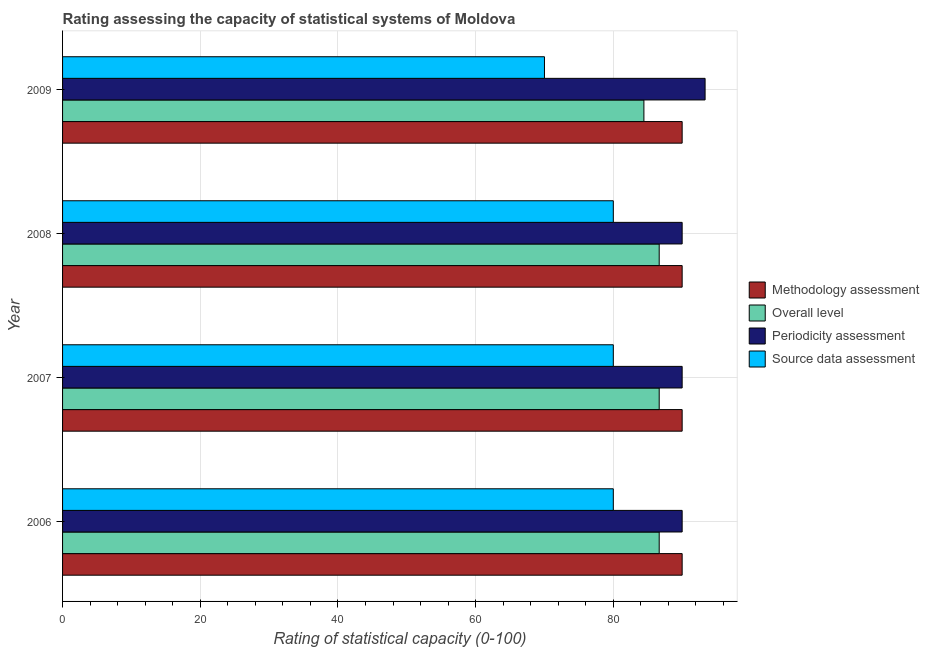How many different coloured bars are there?
Keep it short and to the point. 4. Are the number of bars per tick equal to the number of legend labels?
Your response must be concise. Yes. Are the number of bars on each tick of the Y-axis equal?
Provide a succinct answer. Yes. How many bars are there on the 1st tick from the top?
Your answer should be compact. 4. What is the periodicity assessment rating in 2009?
Keep it short and to the point. 93.33. Across all years, what is the maximum source data assessment rating?
Offer a terse response. 80. Across all years, what is the minimum overall level rating?
Your answer should be very brief. 84.44. In which year was the source data assessment rating minimum?
Provide a short and direct response. 2009. What is the total source data assessment rating in the graph?
Your response must be concise. 310. What is the difference between the overall level rating in 2006 and that in 2009?
Your response must be concise. 2.22. What is the difference between the source data assessment rating in 2008 and the methodology assessment rating in 2009?
Ensure brevity in your answer.  -10. In the year 2009, what is the difference between the periodicity assessment rating and source data assessment rating?
Keep it short and to the point. 23.33. What is the ratio of the source data assessment rating in 2007 to that in 2008?
Keep it short and to the point. 1. What is the difference between the highest and the second highest overall level rating?
Your answer should be very brief. 0. What is the difference between the highest and the lowest periodicity assessment rating?
Provide a succinct answer. 3.33. In how many years, is the source data assessment rating greater than the average source data assessment rating taken over all years?
Provide a succinct answer. 3. Is the sum of the methodology assessment rating in 2006 and 2007 greater than the maximum source data assessment rating across all years?
Offer a terse response. Yes. Is it the case that in every year, the sum of the methodology assessment rating and periodicity assessment rating is greater than the sum of source data assessment rating and overall level rating?
Your answer should be very brief. No. What does the 3rd bar from the top in 2006 represents?
Offer a terse response. Overall level. What does the 4th bar from the bottom in 2006 represents?
Ensure brevity in your answer.  Source data assessment. Is it the case that in every year, the sum of the methodology assessment rating and overall level rating is greater than the periodicity assessment rating?
Keep it short and to the point. Yes. How many legend labels are there?
Keep it short and to the point. 4. What is the title of the graph?
Provide a short and direct response. Rating assessing the capacity of statistical systems of Moldova. Does "Second 20% of population" appear as one of the legend labels in the graph?
Offer a very short reply. No. What is the label or title of the X-axis?
Keep it short and to the point. Rating of statistical capacity (0-100). What is the Rating of statistical capacity (0-100) of Overall level in 2006?
Your answer should be compact. 86.67. What is the Rating of statistical capacity (0-100) in Methodology assessment in 2007?
Offer a very short reply. 90. What is the Rating of statistical capacity (0-100) of Overall level in 2007?
Provide a succinct answer. 86.67. What is the Rating of statistical capacity (0-100) of Periodicity assessment in 2007?
Your answer should be compact. 90. What is the Rating of statistical capacity (0-100) of Source data assessment in 2007?
Offer a very short reply. 80. What is the Rating of statistical capacity (0-100) of Methodology assessment in 2008?
Provide a succinct answer. 90. What is the Rating of statistical capacity (0-100) of Overall level in 2008?
Your response must be concise. 86.67. What is the Rating of statistical capacity (0-100) of Periodicity assessment in 2008?
Ensure brevity in your answer.  90. What is the Rating of statistical capacity (0-100) in Source data assessment in 2008?
Keep it short and to the point. 80. What is the Rating of statistical capacity (0-100) in Methodology assessment in 2009?
Ensure brevity in your answer.  90. What is the Rating of statistical capacity (0-100) of Overall level in 2009?
Make the answer very short. 84.44. What is the Rating of statistical capacity (0-100) of Periodicity assessment in 2009?
Offer a terse response. 93.33. What is the Rating of statistical capacity (0-100) of Source data assessment in 2009?
Keep it short and to the point. 70. Across all years, what is the maximum Rating of statistical capacity (0-100) in Methodology assessment?
Your answer should be compact. 90. Across all years, what is the maximum Rating of statistical capacity (0-100) of Overall level?
Ensure brevity in your answer.  86.67. Across all years, what is the maximum Rating of statistical capacity (0-100) in Periodicity assessment?
Your response must be concise. 93.33. Across all years, what is the maximum Rating of statistical capacity (0-100) of Source data assessment?
Make the answer very short. 80. Across all years, what is the minimum Rating of statistical capacity (0-100) in Methodology assessment?
Your response must be concise. 90. Across all years, what is the minimum Rating of statistical capacity (0-100) of Overall level?
Provide a succinct answer. 84.44. What is the total Rating of statistical capacity (0-100) of Methodology assessment in the graph?
Provide a succinct answer. 360. What is the total Rating of statistical capacity (0-100) of Overall level in the graph?
Offer a terse response. 344.44. What is the total Rating of statistical capacity (0-100) of Periodicity assessment in the graph?
Provide a succinct answer. 363.33. What is the total Rating of statistical capacity (0-100) of Source data assessment in the graph?
Keep it short and to the point. 310. What is the difference between the Rating of statistical capacity (0-100) of Overall level in 2006 and that in 2007?
Provide a succinct answer. 0. What is the difference between the Rating of statistical capacity (0-100) of Periodicity assessment in 2006 and that in 2007?
Offer a very short reply. 0. What is the difference between the Rating of statistical capacity (0-100) of Source data assessment in 2006 and that in 2007?
Ensure brevity in your answer.  0. What is the difference between the Rating of statistical capacity (0-100) in Methodology assessment in 2006 and that in 2008?
Offer a very short reply. 0. What is the difference between the Rating of statistical capacity (0-100) of Methodology assessment in 2006 and that in 2009?
Provide a succinct answer. 0. What is the difference between the Rating of statistical capacity (0-100) of Overall level in 2006 and that in 2009?
Your answer should be very brief. 2.22. What is the difference between the Rating of statistical capacity (0-100) of Periodicity assessment in 2006 and that in 2009?
Offer a very short reply. -3.33. What is the difference between the Rating of statistical capacity (0-100) in Source data assessment in 2006 and that in 2009?
Make the answer very short. 10. What is the difference between the Rating of statistical capacity (0-100) of Overall level in 2007 and that in 2008?
Your response must be concise. 0. What is the difference between the Rating of statistical capacity (0-100) in Periodicity assessment in 2007 and that in 2008?
Offer a very short reply. 0. What is the difference between the Rating of statistical capacity (0-100) of Source data assessment in 2007 and that in 2008?
Your answer should be very brief. 0. What is the difference between the Rating of statistical capacity (0-100) in Overall level in 2007 and that in 2009?
Your answer should be compact. 2.22. What is the difference between the Rating of statistical capacity (0-100) in Source data assessment in 2007 and that in 2009?
Offer a very short reply. 10. What is the difference between the Rating of statistical capacity (0-100) in Overall level in 2008 and that in 2009?
Your answer should be very brief. 2.22. What is the difference between the Rating of statistical capacity (0-100) in Periodicity assessment in 2008 and that in 2009?
Give a very brief answer. -3.33. What is the difference between the Rating of statistical capacity (0-100) in Source data assessment in 2008 and that in 2009?
Provide a succinct answer. 10. What is the difference between the Rating of statistical capacity (0-100) in Methodology assessment in 2006 and the Rating of statistical capacity (0-100) in Overall level in 2007?
Provide a succinct answer. 3.33. What is the difference between the Rating of statistical capacity (0-100) in Periodicity assessment in 2006 and the Rating of statistical capacity (0-100) in Source data assessment in 2007?
Offer a very short reply. 10. What is the difference between the Rating of statistical capacity (0-100) in Methodology assessment in 2006 and the Rating of statistical capacity (0-100) in Overall level in 2008?
Provide a short and direct response. 3.33. What is the difference between the Rating of statistical capacity (0-100) of Methodology assessment in 2006 and the Rating of statistical capacity (0-100) of Periodicity assessment in 2008?
Your answer should be very brief. 0. What is the difference between the Rating of statistical capacity (0-100) in Overall level in 2006 and the Rating of statistical capacity (0-100) in Source data assessment in 2008?
Make the answer very short. 6.67. What is the difference between the Rating of statistical capacity (0-100) of Methodology assessment in 2006 and the Rating of statistical capacity (0-100) of Overall level in 2009?
Provide a short and direct response. 5.56. What is the difference between the Rating of statistical capacity (0-100) in Methodology assessment in 2006 and the Rating of statistical capacity (0-100) in Periodicity assessment in 2009?
Offer a terse response. -3.33. What is the difference between the Rating of statistical capacity (0-100) in Overall level in 2006 and the Rating of statistical capacity (0-100) in Periodicity assessment in 2009?
Make the answer very short. -6.67. What is the difference between the Rating of statistical capacity (0-100) of Overall level in 2006 and the Rating of statistical capacity (0-100) of Source data assessment in 2009?
Keep it short and to the point. 16.67. What is the difference between the Rating of statistical capacity (0-100) in Methodology assessment in 2007 and the Rating of statistical capacity (0-100) in Source data assessment in 2008?
Offer a terse response. 10. What is the difference between the Rating of statistical capacity (0-100) of Overall level in 2007 and the Rating of statistical capacity (0-100) of Periodicity assessment in 2008?
Your response must be concise. -3.33. What is the difference between the Rating of statistical capacity (0-100) of Overall level in 2007 and the Rating of statistical capacity (0-100) of Source data assessment in 2008?
Give a very brief answer. 6.67. What is the difference between the Rating of statistical capacity (0-100) in Periodicity assessment in 2007 and the Rating of statistical capacity (0-100) in Source data assessment in 2008?
Ensure brevity in your answer.  10. What is the difference between the Rating of statistical capacity (0-100) of Methodology assessment in 2007 and the Rating of statistical capacity (0-100) of Overall level in 2009?
Ensure brevity in your answer.  5.56. What is the difference between the Rating of statistical capacity (0-100) of Methodology assessment in 2007 and the Rating of statistical capacity (0-100) of Periodicity assessment in 2009?
Your response must be concise. -3.33. What is the difference between the Rating of statistical capacity (0-100) of Methodology assessment in 2007 and the Rating of statistical capacity (0-100) of Source data assessment in 2009?
Provide a succinct answer. 20. What is the difference between the Rating of statistical capacity (0-100) of Overall level in 2007 and the Rating of statistical capacity (0-100) of Periodicity assessment in 2009?
Offer a terse response. -6.67. What is the difference between the Rating of statistical capacity (0-100) in Overall level in 2007 and the Rating of statistical capacity (0-100) in Source data assessment in 2009?
Provide a succinct answer. 16.67. What is the difference between the Rating of statistical capacity (0-100) of Periodicity assessment in 2007 and the Rating of statistical capacity (0-100) of Source data assessment in 2009?
Give a very brief answer. 20. What is the difference between the Rating of statistical capacity (0-100) of Methodology assessment in 2008 and the Rating of statistical capacity (0-100) of Overall level in 2009?
Your answer should be compact. 5.56. What is the difference between the Rating of statistical capacity (0-100) in Methodology assessment in 2008 and the Rating of statistical capacity (0-100) in Source data assessment in 2009?
Offer a very short reply. 20. What is the difference between the Rating of statistical capacity (0-100) in Overall level in 2008 and the Rating of statistical capacity (0-100) in Periodicity assessment in 2009?
Make the answer very short. -6.67. What is the difference between the Rating of statistical capacity (0-100) in Overall level in 2008 and the Rating of statistical capacity (0-100) in Source data assessment in 2009?
Your answer should be compact. 16.67. What is the difference between the Rating of statistical capacity (0-100) in Periodicity assessment in 2008 and the Rating of statistical capacity (0-100) in Source data assessment in 2009?
Your response must be concise. 20. What is the average Rating of statistical capacity (0-100) of Methodology assessment per year?
Give a very brief answer. 90. What is the average Rating of statistical capacity (0-100) of Overall level per year?
Ensure brevity in your answer.  86.11. What is the average Rating of statistical capacity (0-100) of Periodicity assessment per year?
Offer a very short reply. 90.83. What is the average Rating of statistical capacity (0-100) of Source data assessment per year?
Provide a succinct answer. 77.5. In the year 2006, what is the difference between the Rating of statistical capacity (0-100) of Methodology assessment and Rating of statistical capacity (0-100) of Periodicity assessment?
Offer a terse response. 0. In the year 2006, what is the difference between the Rating of statistical capacity (0-100) in Overall level and Rating of statistical capacity (0-100) in Periodicity assessment?
Provide a succinct answer. -3.33. In the year 2006, what is the difference between the Rating of statistical capacity (0-100) in Overall level and Rating of statistical capacity (0-100) in Source data assessment?
Offer a terse response. 6.67. In the year 2006, what is the difference between the Rating of statistical capacity (0-100) in Periodicity assessment and Rating of statistical capacity (0-100) in Source data assessment?
Give a very brief answer. 10. In the year 2007, what is the difference between the Rating of statistical capacity (0-100) in Methodology assessment and Rating of statistical capacity (0-100) in Overall level?
Offer a very short reply. 3.33. In the year 2007, what is the difference between the Rating of statistical capacity (0-100) of Methodology assessment and Rating of statistical capacity (0-100) of Periodicity assessment?
Give a very brief answer. 0. In the year 2007, what is the difference between the Rating of statistical capacity (0-100) of Methodology assessment and Rating of statistical capacity (0-100) of Source data assessment?
Your answer should be compact. 10. In the year 2008, what is the difference between the Rating of statistical capacity (0-100) in Methodology assessment and Rating of statistical capacity (0-100) in Periodicity assessment?
Provide a succinct answer. 0. In the year 2008, what is the difference between the Rating of statistical capacity (0-100) in Overall level and Rating of statistical capacity (0-100) in Periodicity assessment?
Your response must be concise. -3.33. In the year 2008, what is the difference between the Rating of statistical capacity (0-100) of Periodicity assessment and Rating of statistical capacity (0-100) of Source data assessment?
Provide a short and direct response. 10. In the year 2009, what is the difference between the Rating of statistical capacity (0-100) in Methodology assessment and Rating of statistical capacity (0-100) in Overall level?
Offer a very short reply. 5.56. In the year 2009, what is the difference between the Rating of statistical capacity (0-100) in Methodology assessment and Rating of statistical capacity (0-100) in Periodicity assessment?
Offer a terse response. -3.33. In the year 2009, what is the difference between the Rating of statistical capacity (0-100) of Methodology assessment and Rating of statistical capacity (0-100) of Source data assessment?
Provide a succinct answer. 20. In the year 2009, what is the difference between the Rating of statistical capacity (0-100) in Overall level and Rating of statistical capacity (0-100) in Periodicity assessment?
Offer a terse response. -8.89. In the year 2009, what is the difference between the Rating of statistical capacity (0-100) of Overall level and Rating of statistical capacity (0-100) of Source data assessment?
Your response must be concise. 14.44. In the year 2009, what is the difference between the Rating of statistical capacity (0-100) in Periodicity assessment and Rating of statistical capacity (0-100) in Source data assessment?
Your response must be concise. 23.33. What is the ratio of the Rating of statistical capacity (0-100) of Overall level in 2006 to that in 2007?
Make the answer very short. 1. What is the ratio of the Rating of statistical capacity (0-100) of Source data assessment in 2006 to that in 2007?
Provide a short and direct response. 1. What is the ratio of the Rating of statistical capacity (0-100) in Methodology assessment in 2006 to that in 2008?
Offer a very short reply. 1. What is the ratio of the Rating of statistical capacity (0-100) of Periodicity assessment in 2006 to that in 2008?
Keep it short and to the point. 1. What is the ratio of the Rating of statistical capacity (0-100) in Methodology assessment in 2006 to that in 2009?
Ensure brevity in your answer.  1. What is the ratio of the Rating of statistical capacity (0-100) in Overall level in 2006 to that in 2009?
Offer a very short reply. 1.03. What is the ratio of the Rating of statistical capacity (0-100) in Periodicity assessment in 2006 to that in 2009?
Your answer should be very brief. 0.96. What is the ratio of the Rating of statistical capacity (0-100) in Overall level in 2007 to that in 2008?
Your response must be concise. 1. What is the ratio of the Rating of statistical capacity (0-100) of Periodicity assessment in 2007 to that in 2008?
Provide a short and direct response. 1. What is the ratio of the Rating of statistical capacity (0-100) in Source data assessment in 2007 to that in 2008?
Offer a terse response. 1. What is the ratio of the Rating of statistical capacity (0-100) of Methodology assessment in 2007 to that in 2009?
Give a very brief answer. 1. What is the ratio of the Rating of statistical capacity (0-100) of Overall level in 2007 to that in 2009?
Give a very brief answer. 1.03. What is the ratio of the Rating of statistical capacity (0-100) of Source data assessment in 2007 to that in 2009?
Your answer should be compact. 1.14. What is the ratio of the Rating of statistical capacity (0-100) of Methodology assessment in 2008 to that in 2009?
Give a very brief answer. 1. What is the ratio of the Rating of statistical capacity (0-100) in Overall level in 2008 to that in 2009?
Provide a succinct answer. 1.03. What is the ratio of the Rating of statistical capacity (0-100) of Source data assessment in 2008 to that in 2009?
Offer a terse response. 1.14. What is the difference between the highest and the second highest Rating of statistical capacity (0-100) of Overall level?
Ensure brevity in your answer.  0. What is the difference between the highest and the lowest Rating of statistical capacity (0-100) of Overall level?
Your response must be concise. 2.22. 